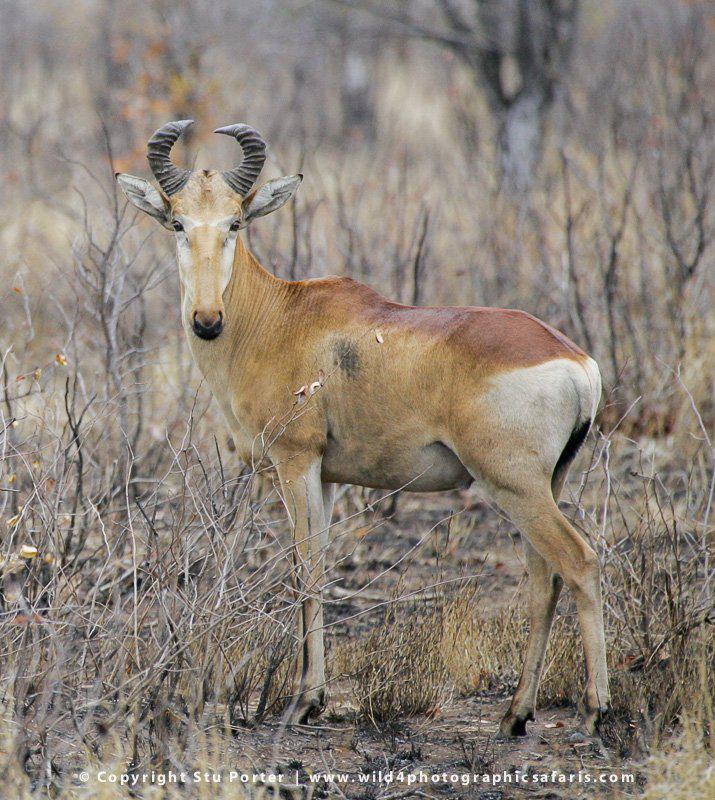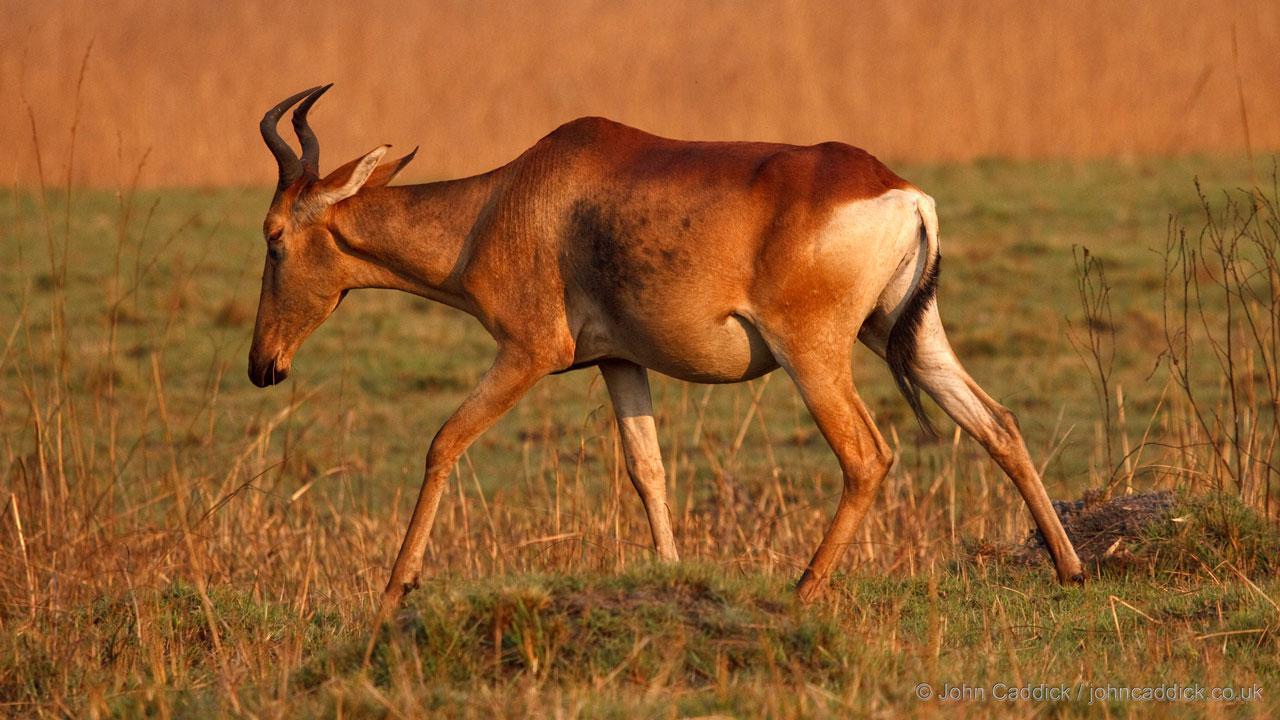The first image is the image on the left, the second image is the image on the right. Examine the images to the left and right. Is the description "The left and right image contains the same number of right facing antelopes." accurate? Answer yes or no. Yes. The first image is the image on the left, the second image is the image on the right. Given the left and right images, does the statement "One animal is heading left with their head turned and looking into the camera." hold true? Answer yes or no. Yes. 